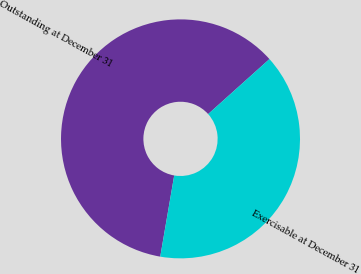<chart> <loc_0><loc_0><loc_500><loc_500><pie_chart><fcel>Outstanding at December 31<fcel>Exercisable at December 31<nl><fcel>60.65%<fcel>39.35%<nl></chart> 